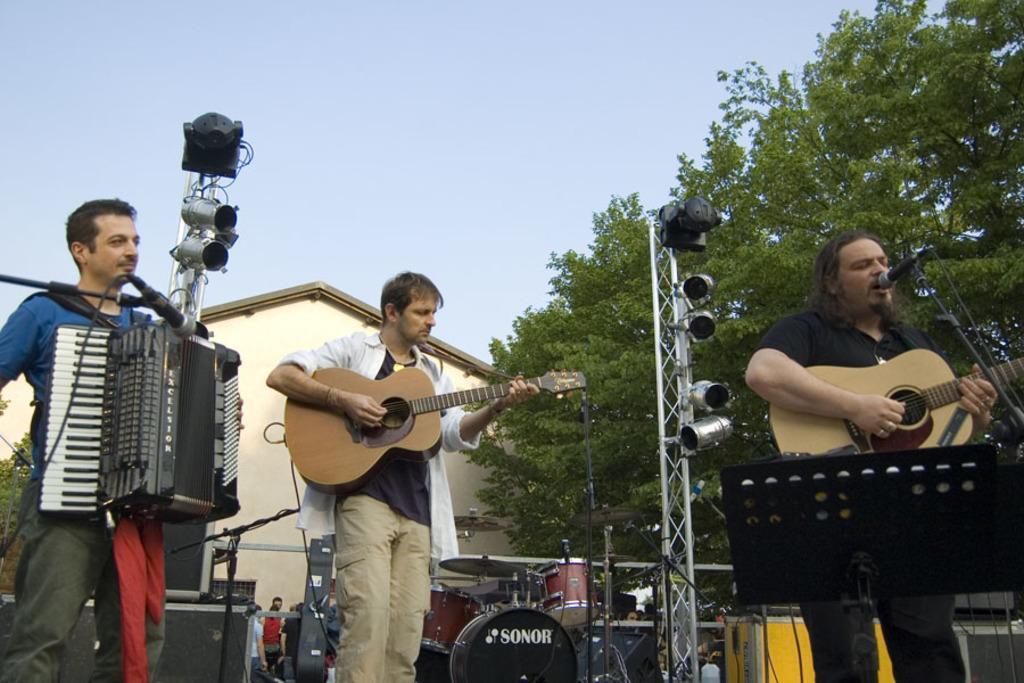Please provide a concise description of this image. Here we see three people standing and two are playing guitar and one person is playing a piano and we see a tree and a house back of them. 